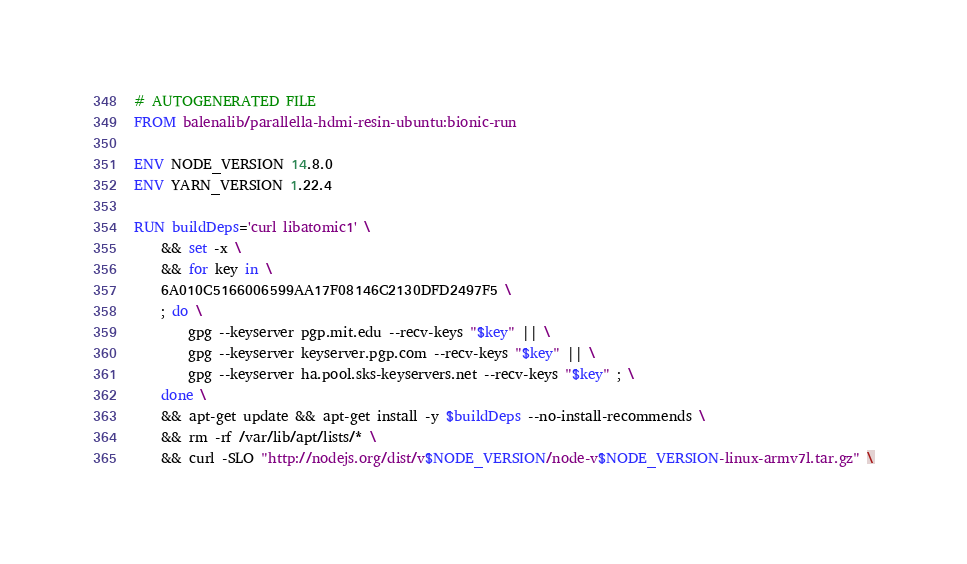<code> <loc_0><loc_0><loc_500><loc_500><_Dockerfile_># AUTOGENERATED FILE
FROM balenalib/parallella-hdmi-resin-ubuntu:bionic-run

ENV NODE_VERSION 14.8.0
ENV YARN_VERSION 1.22.4

RUN buildDeps='curl libatomic1' \
	&& set -x \
	&& for key in \
	6A010C5166006599AA17F08146C2130DFD2497F5 \
	; do \
		gpg --keyserver pgp.mit.edu --recv-keys "$key" || \
		gpg --keyserver keyserver.pgp.com --recv-keys "$key" || \
		gpg --keyserver ha.pool.sks-keyservers.net --recv-keys "$key" ; \
	done \
	&& apt-get update && apt-get install -y $buildDeps --no-install-recommends \
	&& rm -rf /var/lib/apt/lists/* \
	&& curl -SLO "http://nodejs.org/dist/v$NODE_VERSION/node-v$NODE_VERSION-linux-armv7l.tar.gz" \</code> 